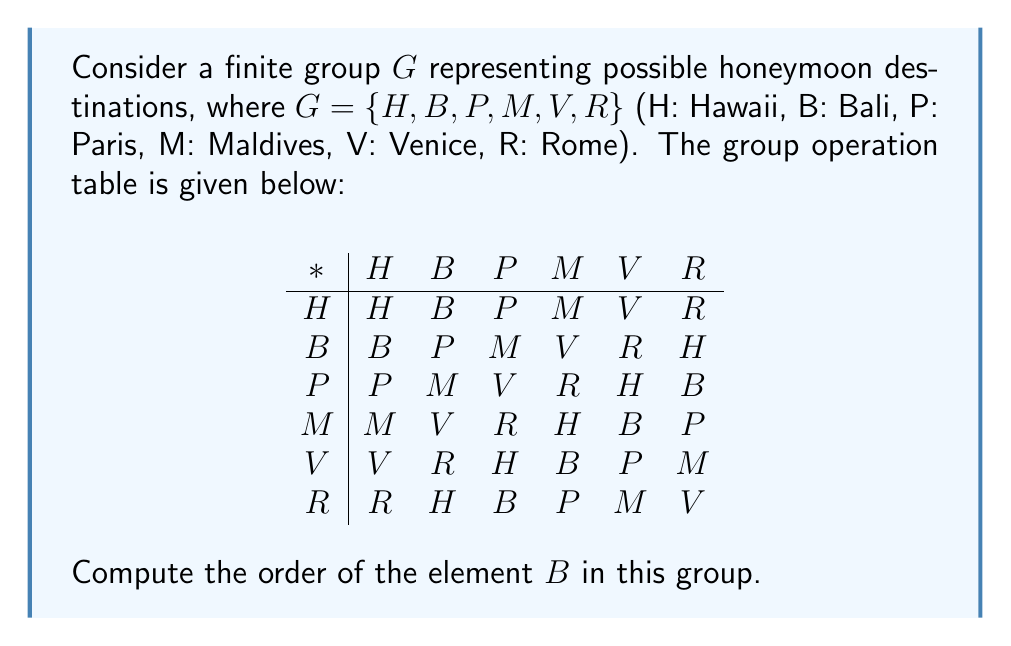Provide a solution to this math problem. To find the order of element $B$ in the group $G$, we need to determine the smallest positive integer $n$ such that $B^n = H$ (the identity element of the group).

Let's compute the powers of $B$:

1. $B^1 = B$
2. $B^2 = B * B = P$ (from the group operation table)
3. $B^3 = B * P = M$ (from the group operation table)
4. $B^4 = B * M = V$ (from the group operation table)
5. $B^5 = B * V = R$ (from the group operation table)
6. $B^6 = B * R = H$ (from the group operation table)

We see that $B^6 = H$, which is the identity element of the group. This is the smallest positive integer $n$ for which $B^n = H$.

Therefore, the order of element $B$ in the group $G$ is 6.

This result is particularly fitting for our friendly mailman who has just become engaged, as it represents the cycle of destinations they might consider for their honeymoon, with each application of $B$ moving them to the next exciting location in the sequence.
Answer: The order of element $B$ in the group $G$ is 6. 